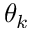Convert formula to latex. <formula><loc_0><loc_0><loc_500><loc_500>\theta _ { k }</formula> 